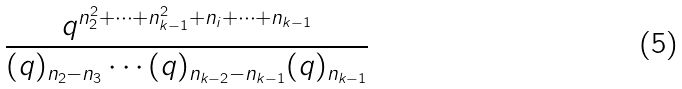Convert formula to latex. <formula><loc_0><loc_0><loc_500><loc_500>\frac { q ^ { n _ { 2 } ^ { 2 } + \cdots + n _ { k - 1 } ^ { 2 } + n _ { i } + \cdots + n _ { k - 1 } } } { ( q ) _ { n _ { 2 } - n _ { 3 } } \cdots ( q ) _ { n _ { k - 2 } - n _ { k - 1 } } ( q ) _ { n _ { k - 1 } } }</formula> 